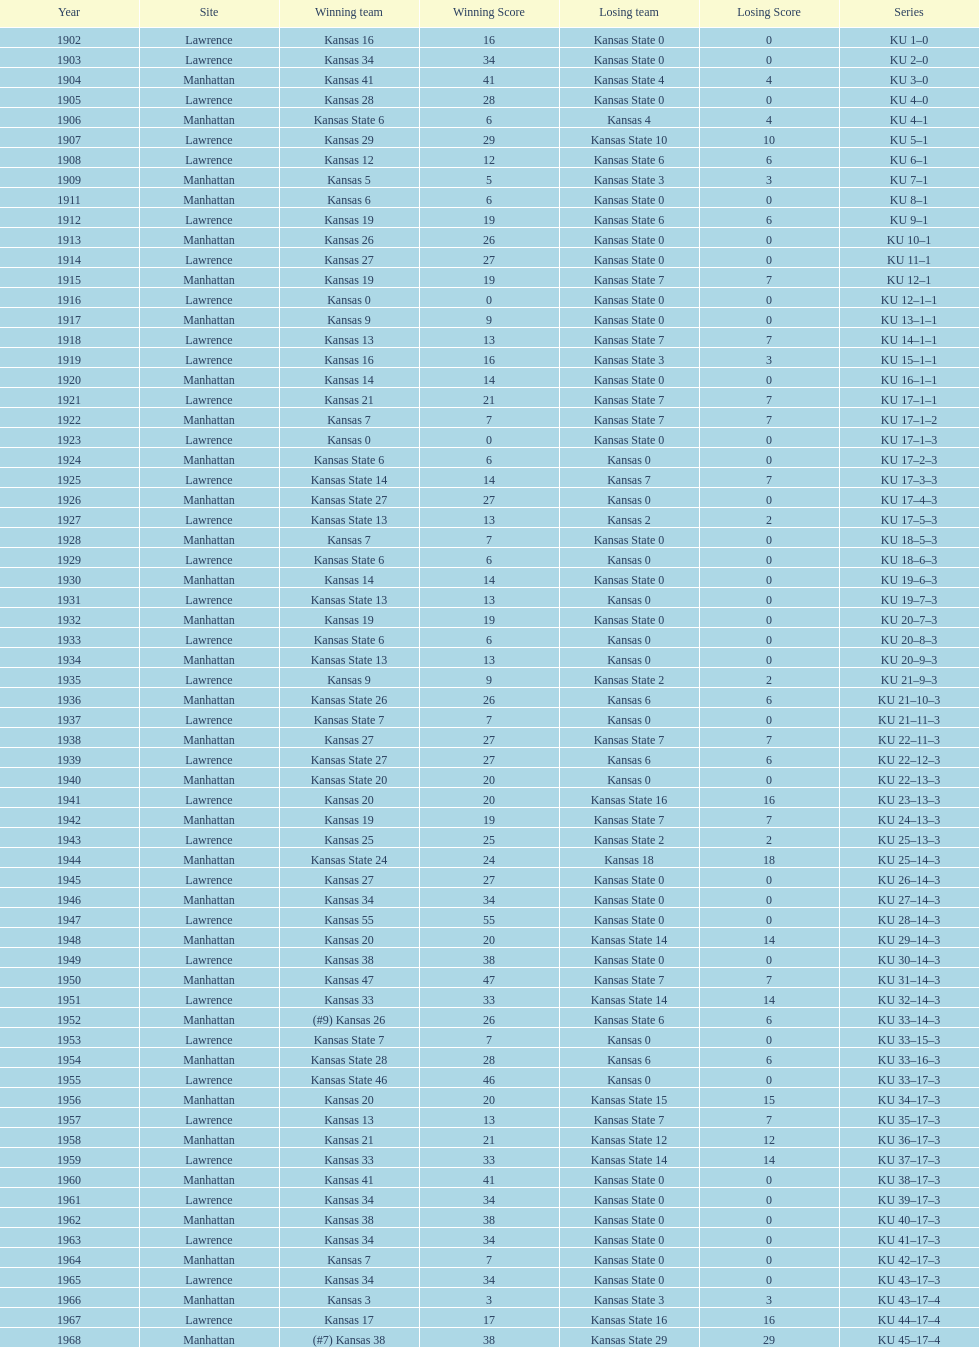Who had the most wins in the 1950's: kansas or kansas state? Kansas. 